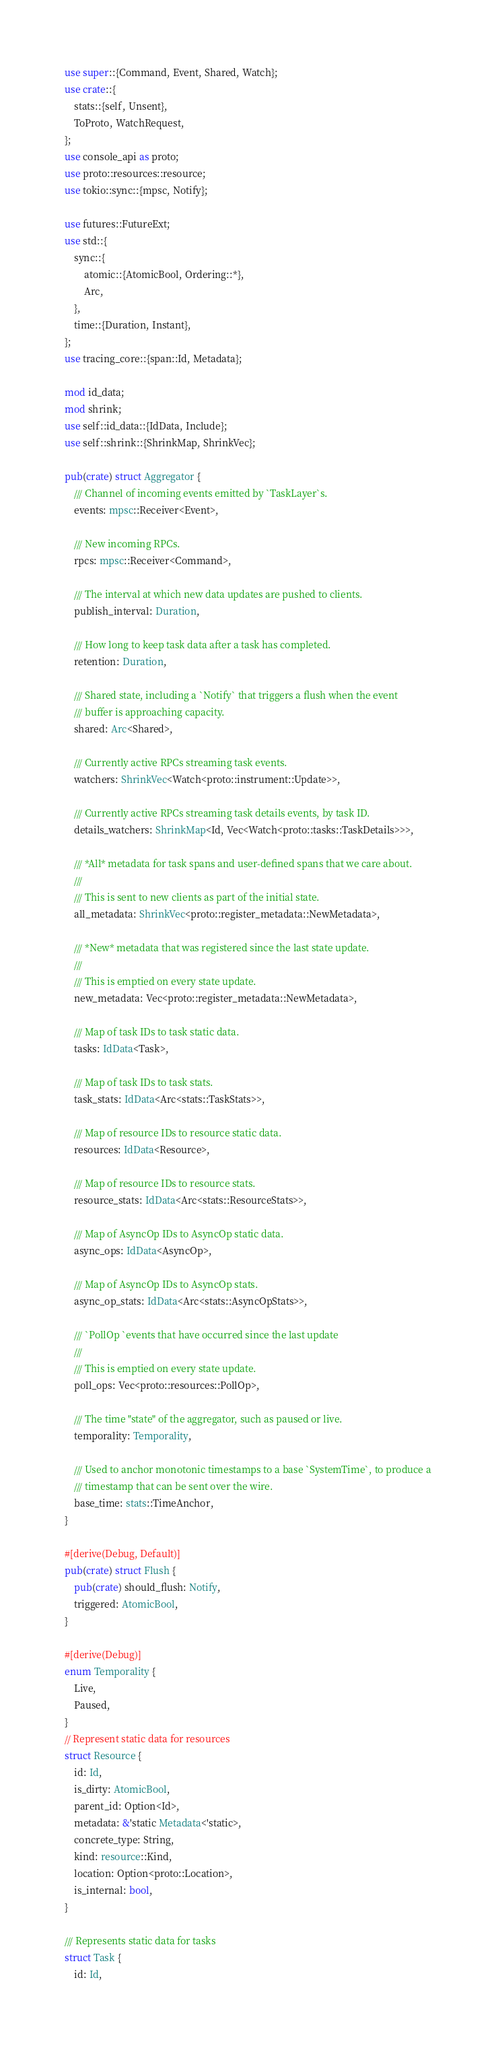<code> <loc_0><loc_0><loc_500><loc_500><_Rust_>use super::{Command, Event, Shared, Watch};
use crate::{
    stats::{self, Unsent},
    ToProto, WatchRequest,
};
use console_api as proto;
use proto::resources::resource;
use tokio::sync::{mpsc, Notify};

use futures::FutureExt;
use std::{
    sync::{
        atomic::{AtomicBool, Ordering::*},
        Arc,
    },
    time::{Duration, Instant},
};
use tracing_core::{span::Id, Metadata};

mod id_data;
mod shrink;
use self::id_data::{IdData, Include};
use self::shrink::{ShrinkMap, ShrinkVec};

pub(crate) struct Aggregator {
    /// Channel of incoming events emitted by `TaskLayer`s.
    events: mpsc::Receiver<Event>,

    /// New incoming RPCs.
    rpcs: mpsc::Receiver<Command>,

    /// The interval at which new data updates are pushed to clients.
    publish_interval: Duration,

    /// How long to keep task data after a task has completed.
    retention: Duration,

    /// Shared state, including a `Notify` that triggers a flush when the event
    /// buffer is approaching capacity.
    shared: Arc<Shared>,

    /// Currently active RPCs streaming task events.
    watchers: ShrinkVec<Watch<proto::instrument::Update>>,

    /// Currently active RPCs streaming task details events, by task ID.
    details_watchers: ShrinkMap<Id, Vec<Watch<proto::tasks::TaskDetails>>>,

    /// *All* metadata for task spans and user-defined spans that we care about.
    ///
    /// This is sent to new clients as part of the initial state.
    all_metadata: ShrinkVec<proto::register_metadata::NewMetadata>,

    /// *New* metadata that was registered since the last state update.
    ///
    /// This is emptied on every state update.
    new_metadata: Vec<proto::register_metadata::NewMetadata>,

    /// Map of task IDs to task static data.
    tasks: IdData<Task>,

    /// Map of task IDs to task stats.
    task_stats: IdData<Arc<stats::TaskStats>>,

    /// Map of resource IDs to resource static data.
    resources: IdData<Resource>,

    /// Map of resource IDs to resource stats.
    resource_stats: IdData<Arc<stats::ResourceStats>>,

    /// Map of AsyncOp IDs to AsyncOp static data.
    async_ops: IdData<AsyncOp>,

    /// Map of AsyncOp IDs to AsyncOp stats.
    async_op_stats: IdData<Arc<stats::AsyncOpStats>>,

    /// `PollOp `events that have occurred since the last update
    ///
    /// This is emptied on every state update.
    poll_ops: Vec<proto::resources::PollOp>,

    /// The time "state" of the aggregator, such as paused or live.
    temporality: Temporality,

    /// Used to anchor monotonic timestamps to a base `SystemTime`, to produce a
    /// timestamp that can be sent over the wire.
    base_time: stats::TimeAnchor,
}

#[derive(Debug, Default)]
pub(crate) struct Flush {
    pub(crate) should_flush: Notify,
    triggered: AtomicBool,
}

#[derive(Debug)]
enum Temporality {
    Live,
    Paused,
}
// Represent static data for resources
struct Resource {
    id: Id,
    is_dirty: AtomicBool,
    parent_id: Option<Id>,
    metadata: &'static Metadata<'static>,
    concrete_type: String,
    kind: resource::Kind,
    location: Option<proto::Location>,
    is_internal: bool,
}

/// Represents static data for tasks
struct Task {
    id: Id,</code> 